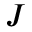Convert formula to latex. <formula><loc_0><loc_0><loc_500><loc_500>J</formula> 